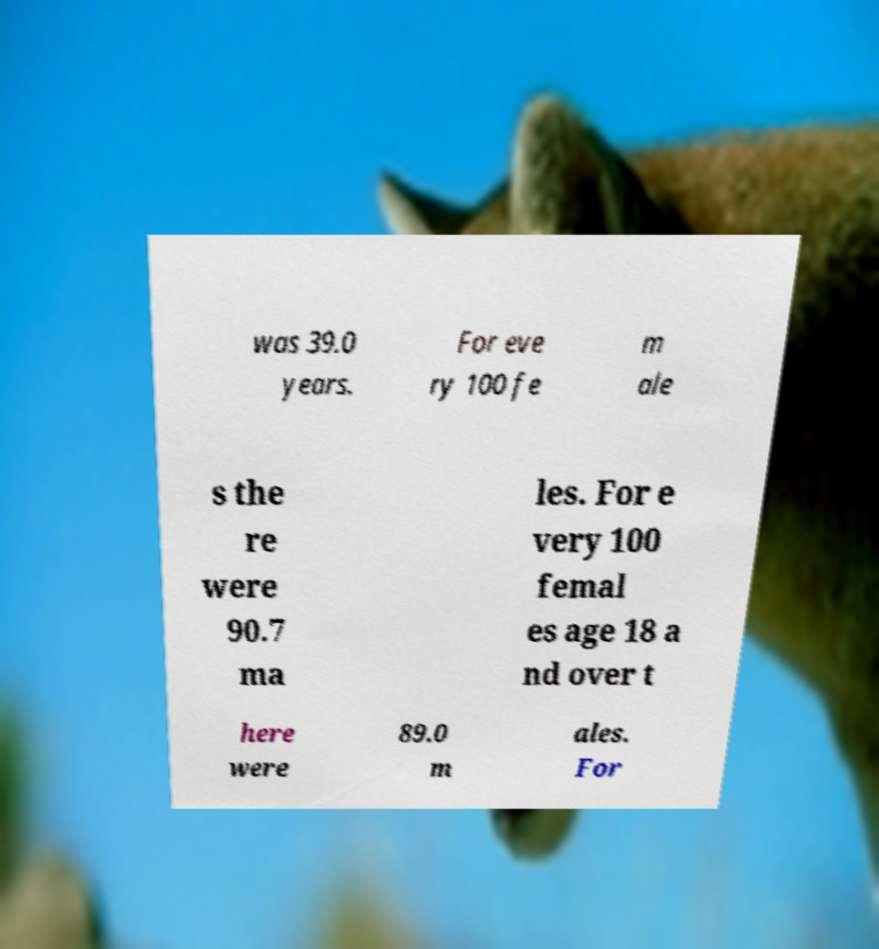I need the written content from this picture converted into text. Can you do that? was 39.0 years. For eve ry 100 fe m ale s the re were 90.7 ma les. For e very 100 femal es age 18 a nd over t here were 89.0 m ales. For 